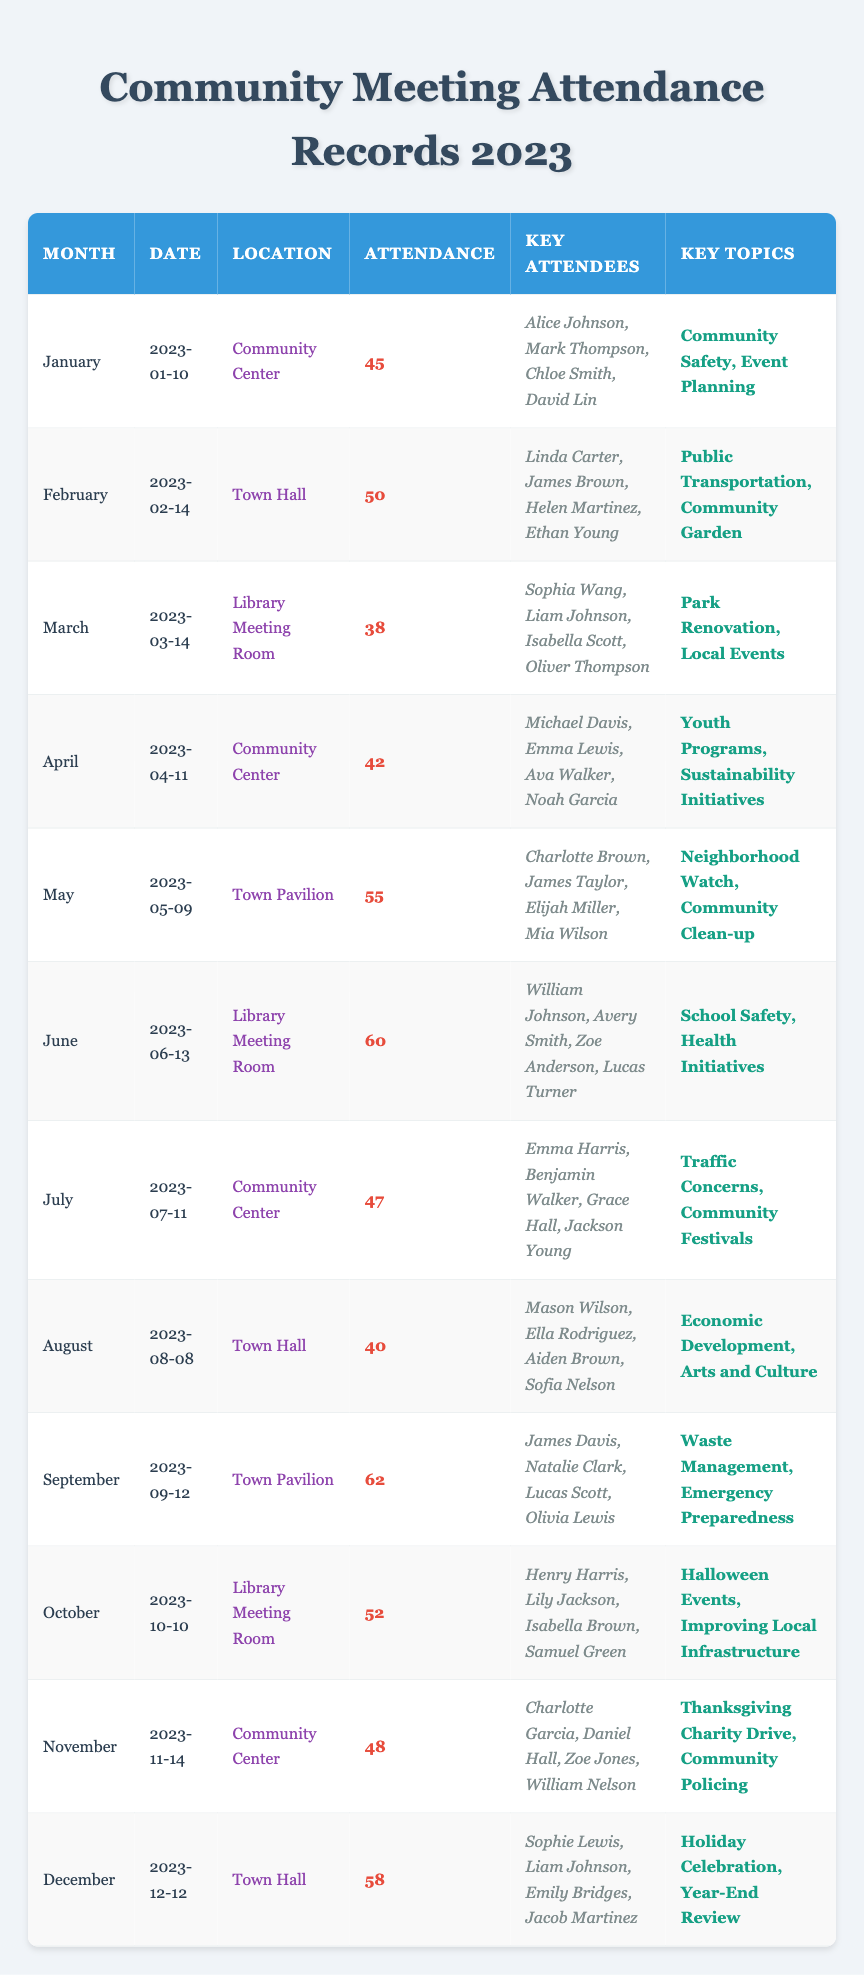What was the highest attendance recorded at a community meeting in 2023? By looking through the attendance column, I see that the highest attendance is 62, which occurred in September.
Answer: 62 Which meeting had the least attendance, and what was the date? The meeting with the least attendance was in March, with 38 attendees, and it occurred on March 14, 2023.
Answer: March 14, 2023 Did more people attend the June meeting than the April meeting? In June, 60 people attended, while in April, there were only 42 attendees. Therefore, yes, more people attended the June meeting.
Answer: Yes What key topics were discussed during the May meeting? The data shows that in May, the key topics discussed were Neighborhood Watch and Community Clean-up.
Answer: Neighborhood Watch, Community Clean-up What is the average attendance across all meetings held in 2023? To calculate the average, I first sum all the attendance values: 45 + 50 + 38 + 42 + 55 + 60 + 47 + 40 + 62 + 52 + 48 + 58 =  587. There are 12 meetings, so the average attendance is 587/12, which equals approximately 48.92.
Answer: 48.92 In which month was the meeting held that discussed Economic Development? According to the table, Economic Development was a key topic discussed in August.
Answer: August How many meetings were held at the Community Center in 2023? By reviewing the location column, I find that the Community Center hosted meetings in January, April, July, and November, totaling 4 meetings.
Answer: 4 Was there a meeting discussing School Safety? If so, when did it occur? Yes, the meeting discussing School Safety took place in June, on June 13, 2023.
Answer: June 13, 2023 What was the total attendance for the meetings held in Town Hall in 2023? In Town Hall, the meetings were held in February (50 attendees), and in August (40 attendees), totaling 50 + 40 = 90 attendees for Town Hall meetings.
Answer: 90 